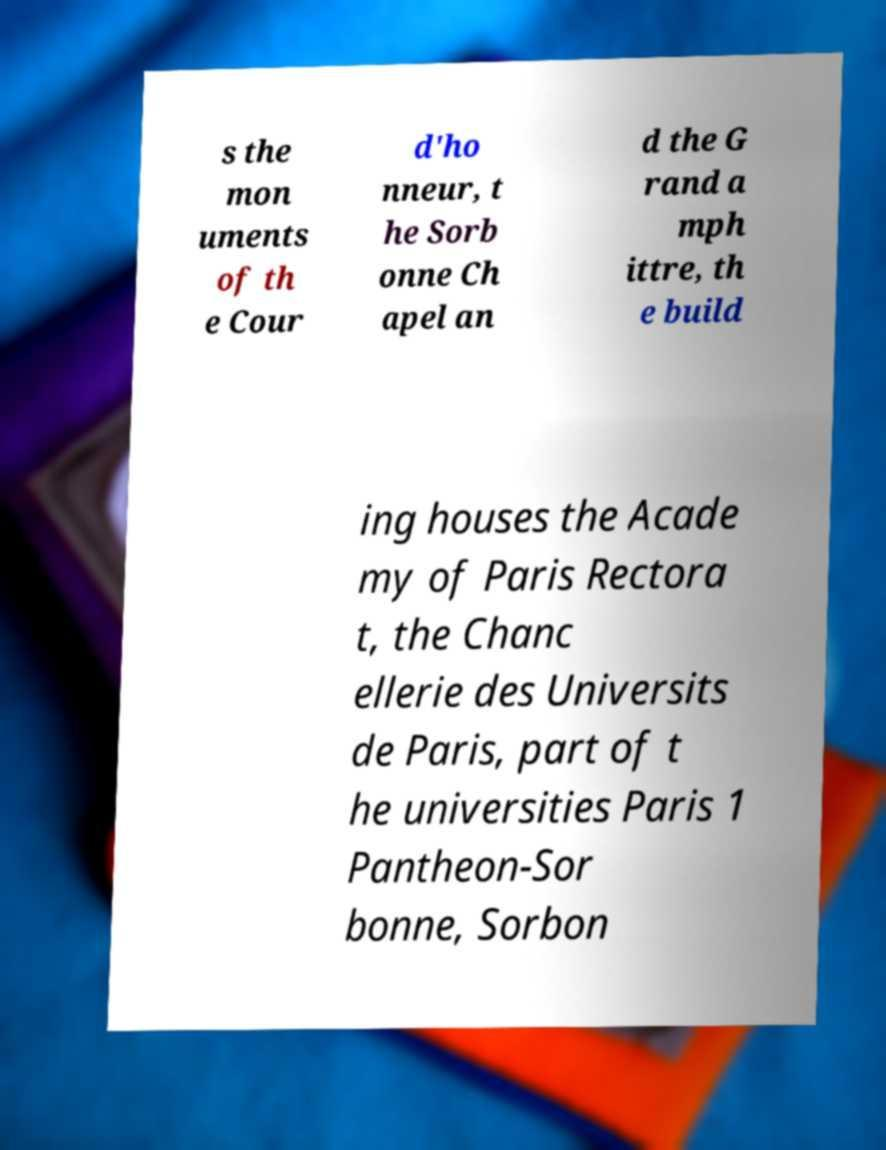Can you accurately transcribe the text from the provided image for me? s the mon uments of th e Cour d'ho nneur, t he Sorb onne Ch apel an d the G rand a mph ittre, th e build ing houses the Acade my of Paris Rectora t, the Chanc ellerie des Universits de Paris, part of t he universities Paris 1 Pantheon-Sor bonne, Sorbon 